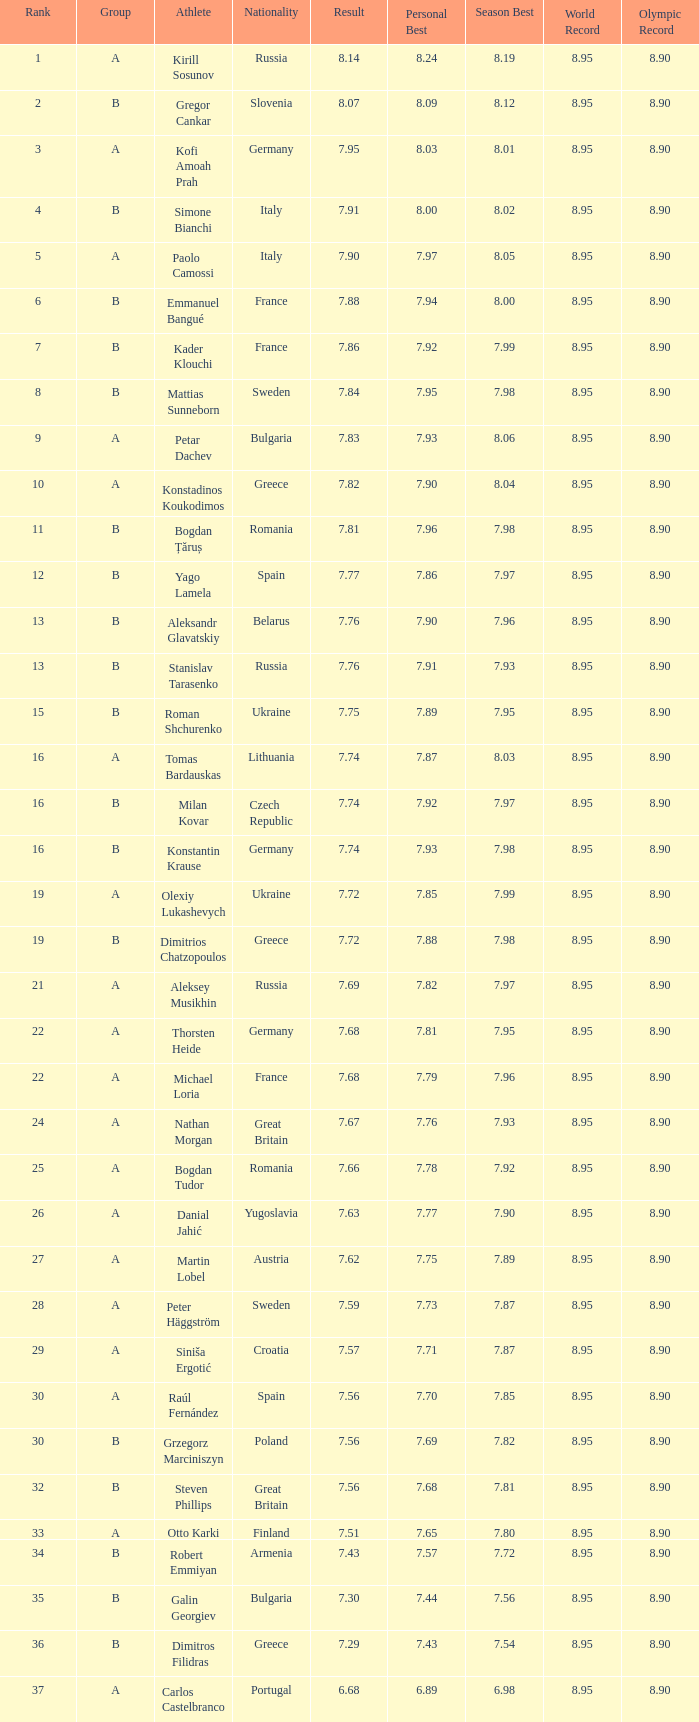Which athlete's rank is more than 15 when the result is less than 7.68, the group is b, and the nationality listed is Great Britain? Steven Phillips. Parse the full table. {'header': ['Rank', 'Group', 'Athlete', 'Nationality', 'Result', 'Personal Best', 'Season Best', 'World Record', 'Olympic Record'], 'rows': [['1', 'A', 'Kirill Sosunov', 'Russia', '8.14', '8.24', '8.19', '8.95', '8.90'], ['2', 'B', 'Gregor Cankar', 'Slovenia', '8.07', '8.09', '8.12', '8.95', '8.90'], ['3', 'A', 'Kofi Amoah Prah', 'Germany', '7.95', '8.03', '8.01', '8.95', '8.90'], ['4', 'B', 'Simone Bianchi', 'Italy', '7.91', '8.00', '8.02', '8.95', '8.90'], ['5', 'A', 'Paolo Camossi', 'Italy', '7.90', '7.97', '8.05', '8.95', '8.90'], ['6', 'B', 'Emmanuel Bangué', 'France', '7.88', '7.94', '8.00', '8.95', '8.90'], ['7', 'B', 'Kader Klouchi', 'France', '7.86', '7.92', '7.99', '8.95', '8.90'], ['8', 'B', 'Mattias Sunneborn', 'Sweden', '7.84', '7.95', '7.98', '8.95', '8.90'], ['9', 'A', 'Petar Dachev', 'Bulgaria', '7.83', '7.93', '8.06', '8.95', '8.90'], ['10', 'A', 'Konstadinos Koukodimos', 'Greece', '7.82', '7.90', '8.04', '8.95', '8.90'], ['11', 'B', 'Bogdan Țăruș', 'Romania', '7.81', '7.96', '7.98', '8.95', '8.90'], ['12', 'B', 'Yago Lamela', 'Spain', '7.77', '7.86', '7.97', '8.95', '8.90'], ['13', 'B', 'Aleksandr Glavatskiy', 'Belarus', '7.76', '7.90', '7.96', '8.95', '8.90'], ['13', 'B', 'Stanislav Tarasenko', 'Russia', '7.76', '7.91', '7.93', '8.95', '8.90'], ['15', 'B', 'Roman Shchurenko', 'Ukraine', '7.75', '7.89', '7.95', '8.95', '8.90'], ['16', 'A', 'Tomas Bardauskas', 'Lithuania', '7.74', '7.87', '8.03', '8.95', '8.90'], ['16', 'B', 'Milan Kovar', 'Czech Republic', '7.74', '7.92', '7.97', '8.95', '8.90'], ['16', 'B', 'Konstantin Krause', 'Germany', '7.74', '7.93', '7.98', '8.95', '8.90'], ['19', 'A', 'Olexiy Lukashevych', 'Ukraine', '7.72', '7.85', '7.99', '8.95', '8.90'], ['19', 'B', 'Dimitrios Chatzopoulos', 'Greece', '7.72', '7.88', '7.98', '8.95', '8.90'], ['21', 'A', 'Aleksey Musikhin', 'Russia', '7.69', '7.82', '7.97', '8.95', '8.90'], ['22', 'A', 'Thorsten Heide', 'Germany', '7.68', '7.81', '7.95', '8.95', '8.90'], ['22', 'A', 'Michael Loria', 'France', '7.68', '7.79', '7.96', '8.95', '8.90'], ['24', 'A', 'Nathan Morgan', 'Great Britain', '7.67', '7.76', '7.93', '8.95', '8.90'], ['25', 'A', 'Bogdan Tudor', 'Romania', '7.66', '7.78', '7.92', '8.95', '8.90'], ['26', 'A', 'Danial Jahić', 'Yugoslavia', '7.63', '7.77', '7.90', '8.95', '8.90'], ['27', 'A', 'Martin Lobel', 'Austria', '7.62', '7.75', '7.89', '8.95', '8.90'], ['28', 'A', 'Peter Häggström', 'Sweden', '7.59', '7.73', '7.87', '8.95', '8.90'], ['29', 'A', 'Siniša Ergotić', 'Croatia', '7.57', '7.71', '7.87', '8.95', '8.90'], ['30', 'A', 'Raúl Fernández', 'Spain', '7.56', '7.70', '7.85', '8.95', '8.90'], ['30', 'B', 'Grzegorz Marciniszyn', 'Poland', '7.56', '7.69', '7.82', '8.95', '8.90'], ['32', 'B', 'Steven Phillips', 'Great Britain', '7.56', '7.68', '7.81', '8.95', '8.90'], ['33', 'A', 'Otto Karki', 'Finland', '7.51', '7.65', '7.80', '8.95', '8.90'], ['34', 'B', 'Robert Emmiyan', 'Armenia', '7.43', '7.57', '7.72', '8.95', '8.90'], ['35', 'B', 'Galin Georgiev', 'Bulgaria', '7.30', '7.44', '7.56', '8.95', '8.90'], ['36', 'B', 'Dimitros Filidras', 'Greece', '7.29', '7.43', '7.54', '8.95', '8.90'], ['37', 'A', 'Carlos Castelbranco', 'Portugal', '6.68', '6.89', '6.98', '8.95', '8.90']]} 